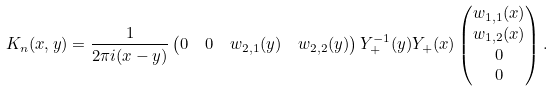Convert formula to latex. <formula><loc_0><loc_0><loc_500><loc_500>K _ { n } ( x , y ) & = \frac { 1 } { 2 \pi i ( x - y ) } \begin{pmatrix} 0 & 0 & w _ { 2 , 1 } ( y ) & w _ { 2 , 2 } ( y ) \end{pmatrix} Y _ { + } ^ { - 1 } ( y ) Y _ { + } ( x ) \begin{pmatrix} w _ { 1 , 1 } ( x ) \\ w _ { 1 , 2 } ( x ) \\ 0 \\ 0 \end{pmatrix} .</formula> 